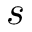Convert formula to latex. <formula><loc_0><loc_0><loc_500><loc_500>s</formula> 